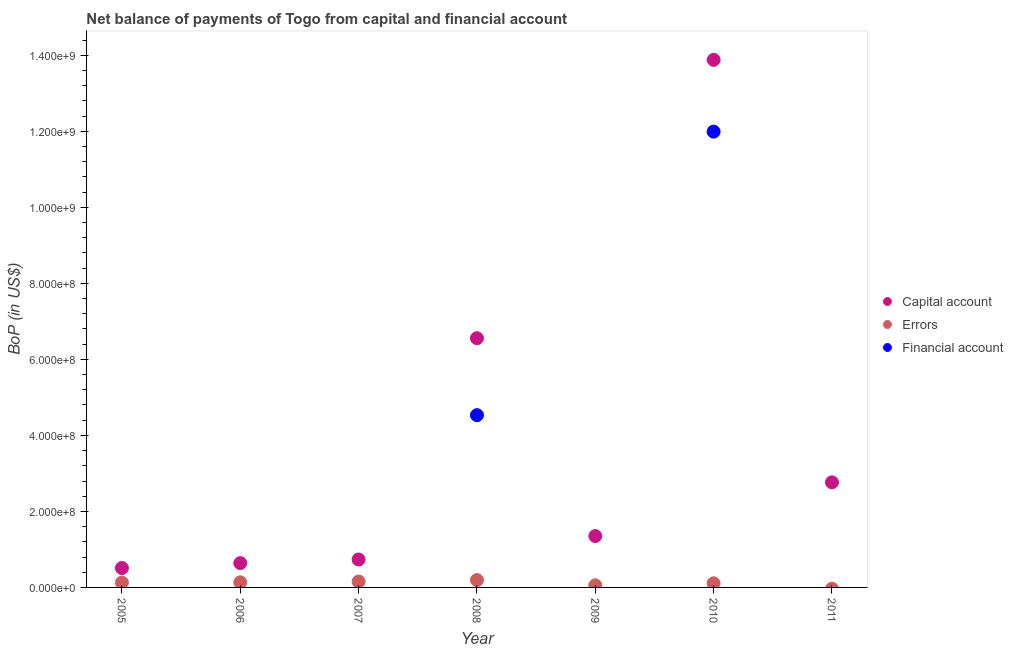How many different coloured dotlines are there?
Your response must be concise. 3. Is the number of dotlines equal to the number of legend labels?
Provide a short and direct response. No. Across all years, what is the maximum amount of net capital account?
Make the answer very short. 1.39e+09. Across all years, what is the minimum amount of financial account?
Provide a succinct answer. 0. What is the total amount of net capital account in the graph?
Make the answer very short. 2.64e+09. What is the difference between the amount of errors in 2008 and that in 2010?
Ensure brevity in your answer.  8.51e+06. What is the difference between the amount of financial account in 2006 and the amount of net capital account in 2005?
Make the answer very short. -5.11e+07. What is the average amount of net capital account per year?
Keep it short and to the point. 3.78e+08. In the year 2010, what is the difference between the amount of financial account and amount of net capital account?
Ensure brevity in your answer.  -1.89e+08. What is the ratio of the amount of net capital account in 2006 to that in 2011?
Your response must be concise. 0.23. What is the difference between the highest and the second highest amount of net capital account?
Your answer should be very brief. 7.32e+08. What is the difference between the highest and the lowest amount of errors?
Your response must be concise. 1.94e+07. In how many years, is the amount of errors greater than the average amount of errors taken over all years?
Keep it short and to the point. 4. Is the sum of the amount of net capital account in 2008 and 2011 greater than the maximum amount of errors across all years?
Keep it short and to the point. Yes. Does the amount of errors monotonically increase over the years?
Offer a terse response. No. Is the amount of net capital account strictly greater than the amount of errors over the years?
Provide a succinct answer. Yes. How many dotlines are there?
Your response must be concise. 3. How many years are there in the graph?
Provide a succinct answer. 7. What is the difference between two consecutive major ticks on the Y-axis?
Make the answer very short. 2.00e+08. Does the graph contain any zero values?
Keep it short and to the point. Yes. Where does the legend appear in the graph?
Your answer should be compact. Center right. How many legend labels are there?
Offer a very short reply. 3. How are the legend labels stacked?
Give a very brief answer. Vertical. What is the title of the graph?
Keep it short and to the point. Net balance of payments of Togo from capital and financial account. Does "Methane" appear as one of the legend labels in the graph?
Your answer should be very brief. No. What is the label or title of the X-axis?
Your answer should be compact. Year. What is the label or title of the Y-axis?
Your answer should be compact. BoP (in US$). What is the BoP (in US$) in Capital account in 2005?
Ensure brevity in your answer.  5.11e+07. What is the BoP (in US$) in Errors in 2005?
Make the answer very short. 1.28e+07. What is the BoP (in US$) in Capital account in 2006?
Ensure brevity in your answer.  6.40e+07. What is the BoP (in US$) of Errors in 2006?
Ensure brevity in your answer.  1.34e+07. What is the BoP (in US$) in Capital account in 2007?
Give a very brief answer. 7.34e+07. What is the BoP (in US$) in Errors in 2007?
Make the answer very short. 1.54e+07. What is the BoP (in US$) in Financial account in 2007?
Ensure brevity in your answer.  0. What is the BoP (in US$) of Capital account in 2008?
Give a very brief answer. 6.56e+08. What is the BoP (in US$) in Errors in 2008?
Provide a succinct answer. 1.94e+07. What is the BoP (in US$) of Financial account in 2008?
Your answer should be compact. 4.53e+08. What is the BoP (in US$) in Capital account in 2009?
Provide a succinct answer. 1.35e+08. What is the BoP (in US$) in Errors in 2009?
Offer a very short reply. 5.51e+06. What is the BoP (in US$) of Financial account in 2009?
Make the answer very short. 0. What is the BoP (in US$) in Capital account in 2010?
Make the answer very short. 1.39e+09. What is the BoP (in US$) of Errors in 2010?
Keep it short and to the point. 1.09e+07. What is the BoP (in US$) in Financial account in 2010?
Give a very brief answer. 1.20e+09. What is the BoP (in US$) of Capital account in 2011?
Offer a very short reply. 2.76e+08. What is the BoP (in US$) of Errors in 2011?
Offer a terse response. 0. Across all years, what is the maximum BoP (in US$) of Capital account?
Provide a succinct answer. 1.39e+09. Across all years, what is the maximum BoP (in US$) of Errors?
Ensure brevity in your answer.  1.94e+07. Across all years, what is the maximum BoP (in US$) in Financial account?
Offer a very short reply. 1.20e+09. Across all years, what is the minimum BoP (in US$) of Capital account?
Provide a succinct answer. 5.11e+07. Across all years, what is the minimum BoP (in US$) in Financial account?
Offer a terse response. 0. What is the total BoP (in US$) in Capital account in the graph?
Your answer should be very brief. 2.64e+09. What is the total BoP (in US$) in Errors in the graph?
Your answer should be compact. 7.73e+07. What is the total BoP (in US$) in Financial account in the graph?
Provide a succinct answer. 1.65e+09. What is the difference between the BoP (in US$) of Capital account in 2005 and that in 2006?
Provide a succinct answer. -1.29e+07. What is the difference between the BoP (in US$) of Errors in 2005 and that in 2006?
Provide a succinct answer. -5.96e+05. What is the difference between the BoP (in US$) in Capital account in 2005 and that in 2007?
Give a very brief answer. -2.24e+07. What is the difference between the BoP (in US$) in Errors in 2005 and that in 2007?
Your response must be concise. -2.56e+06. What is the difference between the BoP (in US$) in Capital account in 2005 and that in 2008?
Provide a succinct answer. -6.05e+08. What is the difference between the BoP (in US$) of Errors in 2005 and that in 2008?
Offer a terse response. -6.60e+06. What is the difference between the BoP (in US$) in Capital account in 2005 and that in 2009?
Your answer should be compact. -8.41e+07. What is the difference between the BoP (in US$) of Errors in 2005 and that in 2009?
Provide a succinct answer. 7.29e+06. What is the difference between the BoP (in US$) of Capital account in 2005 and that in 2010?
Offer a terse response. -1.34e+09. What is the difference between the BoP (in US$) of Errors in 2005 and that in 2010?
Give a very brief answer. 1.91e+06. What is the difference between the BoP (in US$) of Capital account in 2005 and that in 2011?
Make the answer very short. -2.25e+08. What is the difference between the BoP (in US$) of Capital account in 2006 and that in 2007?
Provide a short and direct response. -9.43e+06. What is the difference between the BoP (in US$) of Errors in 2006 and that in 2007?
Give a very brief answer. -1.96e+06. What is the difference between the BoP (in US$) of Capital account in 2006 and that in 2008?
Ensure brevity in your answer.  -5.92e+08. What is the difference between the BoP (in US$) in Errors in 2006 and that in 2008?
Provide a short and direct response. -6.00e+06. What is the difference between the BoP (in US$) in Capital account in 2006 and that in 2009?
Offer a very short reply. -7.12e+07. What is the difference between the BoP (in US$) of Errors in 2006 and that in 2009?
Your answer should be very brief. 7.88e+06. What is the difference between the BoP (in US$) of Capital account in 2006 and that in 2010?
Ensure brevity in your answer.  -1.32e+09. What is the difference between the BoP (in US$) of Errors in 2006 and that in 2010?
Give a very brief answer. 2.50e+06. What is the difference between the BoP (in US$) in Capital account in 2006 and that in 2011?
Make the answer very short. -2.12e+08. What is the difference between the BoP (in US$) of Capital account in 2007 and that in 2008?
Keep it short and to the point. -5.82e+08. What is the difference between the BoP (in US$) of Errors in 2007 and that in 2008?
Ensure brevity in your answer.  -4.04e+06. What is the difference between the BoP (in US$) in Capital account in 2007 and that in 2009?
Your answer should be compact. -6.17e+07. What is the difference between the BoP (in US$) in Errors in 2007 and that in 2009?
Ensure brevity in your answer.  9.85e+06. What is the difference between the BoP (in US$) in Capital account in 2007 and that in 2010?
Provide a short and direct response. -1.31e+09. What is the difference between the BoP (in US$) of Errors in 2007 and that in 2010?
Provide a short and direct response. 4.47e+06. What is the difference between the BoP (in US$) in Capital account in 2007 and that in 2011?
Provide a succinct answer. -2.03e+08. What is the difference between the BoP (in US$) of Capital account in 2008 and that in 2009?
Offer a very short reply. 5.21e+08. What is the difference between the BoP (in US$) in Errors in 2008 and that in 2009?
Your response must be concise. 1.39e+07. What is the difference between the BoP (in US$) in Capital account in 2008 and that in 2010?
Give a very brief answer. -7.32e+08. What is the difference between the BoP (in US$) in Errors in 2008 and that in 2010?
Give a very brief answer. 8.51e+06. What is the difference between the BoP (in US$) in Financial account in 2008 and that in 2010?
Your response must be concise. -7.46e+08. What is the difference between the BoP (in US$) of Capital account in 2008 and that in 2011?
Offer a very short reply. 3.79e+08. What is the difference between the BoP (in US$) of Capital account in 2009 and that in 2010?
Make the answer very short. -1.25e+09. What is the difference between the BoP (in US$) in Errors in 2009 and that in 2010?
Offer a very short reply. -5.38e+06. What is the difference between the BoP (in US$) of Capital account in 2009 and that in 2011?
Provide a succinct answer. -1.41e+08. What is the difference between the BoP (in US$) of Capital account in 2010 and that in 2011?
Your response must be concise. 1.11e+09. What is the difference between the BoP (in US$) of Capital account in 2005 and the BoP (in US$) of Errors in 2006?
Your answer should be very brief. 3.77e+07. What is the difference between the BoP (in US$) of Capital account in 2005 and the BoP (in US$) of Errors in 2007?
Give a very brief answer. 3.57e+07. What is the difference between the BoP (in US$) in Capital account in 2005 and the BoP (in US$) in Errors in 2008?
Offer a terse response. 3.17e+07. What is the difference between the BoP (in US$) in Capital account in 2005 and the BoP (in US$) in Financial account in 2008?
Provide a succinct answer. -4.02e+08. What is the difference between the BoP (in US$) in Errors in 2005 and the BoP (in US$) in Financial account in 2008?
Your answer should be very brief. -4.40e+08. What is the difference between the BoP (in US$) in Capital account in 2005 and the BoP (in US$) in Errors in 2009?
Keep it short and to the point. 4.55e+07. What is the difference between the BoP (in US$) of Capital account in 2005 and the BoP (in US$) of Errors in 2010?
Your answer should be very brief. 4.02e+07. What is the difference between the BoP (in US$) in Capital account in 2005 and the BoP (in US$) in Financial account in 2010?
Ensure brevity in your answer.  -1.15e+09. What is the difference between the BoP (in US$) in Errors in 2005 and the BoP (in US$) in Financial account in 2010?
Your response must be concise. -1.19e+09. What is the difference between the BoP (in US$) of Capital account in 2006 and the BoP (in US$) of Errors in 2007?
Your response must be concise. 4.86e+07. What is the difference between the BoP (in US$) of Capital account in 2006 and the BoP (in US$) of Errors in 2008?
Your answer should be very brief. 4.46e+07. What is the difference between the BoP (in US$) in Capital account in 2006 and the BoP (in US$) in Financial account in 2008?
Offer a terse response. -3.89e+08. What is the difference between the BoP (in US$) in Errors in 2006 and the BoP (in US$) in Financial account in 2008?
Your response must be concise. -4.40e+08. What is the difference between the BoP (in US$) in Capital account in 2006 and the BoP (in US$) in Errors in 2009?
Your answer should be compact. 5.85e+07. What is the difference between the BoP (in US$) in Capital account in 2006 and the BoP (in US$) in Errors in 2010?
Make the answer very short. 5.31e+07. What is the difference between the BoP (in US$) of Capital account in 2006 and the BoP (in US$) of Financial account in 2010?
Your answer should be compact. -1.14e+09. What is the difference between the BoP (in US$) of Errors in 2006 and the BoP (in US$) of Financial account in 2010?
Your answer should be compact. -1.19e+09. What is the difference between the BoP (in US$) in Capital account in 2007 and the BoP (in US$) in Errors in 2008?
Offer a terse response. 5.40e+07. What is the difference between the BoP (in US$) in Capital account in 2007 and the BoP (in US$) in Financial account in 2008?
Give a very brief answer. -3.80e+08. What is the difference between the BoP (in US$) of Errors in 2007 and the BoP (in US$) of Financial account in 2008?
Offer a terse response. -4.38e+08. What is the difference between the BoP (in US$) of Capital account in 2007 and the BoP (in US$) of Errors in 2009?
Ensure brevity in your answer.  6.79e+07. What is the difference between the BoP (in US$) of Capital account in 2007 and the BoP (in US$) of Errors in 2010?
Make the answer very short. 6.25e+07. What is the difference between the BoP (in US$) of Capital account in 2007 and the BoP (in US$) of Financial account in 2010?
Your response must be concise. -1.13e+09. What is the difference between the BoP (in US$) of Errors in 2007 and the BoP (in US$) of Financial account in 2010?
Ensure brevity in your answer.  -1.18e+09. What is the difference between the BoP (in US$) of Capital account in 2008 and the BoP (in US$) of Errors in 2009?
Your answer should be compact. 6.50e+08. What is the difference between the BoP (in US$) in Capital account in 2008 and the BoP (in US$) in Errors in 2010?
Your answer should be very brief. 6.45e+08. What is the difference between the BoP (in US$) in Capital account in 2008 and the BoP (in US$) in Financial account in 2010?
Ensure brevity in your answer.  -5.43e+08. What is the difference between the BoP (in US$) in Errors in 2008 and the BoP (in US$) in Financial account in 2010?
Ensure brevity in your answer.  -1.18e+09. What is the difference between the BoP (in US$) of Capital account in 2009 and the BoP (in US$) of Errors in 2010?
Provide a succinct answer. 1.24e+08. What is the difference between the BoP (in US$) of Capital account in 2009 and the BoP (in US$) of Financial account in 2010?
Give a very brief answer. -1.06e+09. What is the difference between the BoP (in US$) in Errors in 2009 and the BoP (in US$) in Financial account in 2010?
Give a very brief answer. -1.19e+09. What is the average BoP (in US$) of Capital account per year?
Your answer should be compact. 3.78e+08. What is the average BoP (in US$) of Errors per year?
Your response must be concise. 1.10e+07. What is the average BoP (in US$) in Financial account per year?
Offer a very short reply. 2.36e+08. In the year 2005, what is the difference between the BoP (in US$) of Capital account and BoP (in US$) of Errors?
Provide a succinct answer. 3.83e+07. In the year 2006, what is the difference between the BoP (in US$) in Capital account and BoP (in US$) in Errors?
Give a very brief answer. 5.06e+07. In the year 2007, what is the difference between the BoP (in US$) of Capital account and BoP (in US$) of Errors?
Your answer should be compact. 5.81e+07. In the year 2008, what is the difference between the BoP (in US$) of Capital account and BoP (in US$) of Errors?
Your response must be concise. 6.36e+08. In the year 2008, what is the difference between the BoP (in US$) in Capital account and BoP (in US$) in Financial account?
Provide a succinct answer. 2.03e+08. In the year 2008, what is the difference between the BoP (in US$) in Errors and BoP (in US$) in Financial account?
Provide a succinct answer. -4.34e+08. In the year 2009, what is the difference between the BoP (in US$) in Capital account and BoP (in US$) in Errors?
Your response must be concise. 1.30e+08. In the year 2010, what is the difference between the BoP (in US$) in Capital account and BoP (in US$) in Errors?
Offer a very short reply. 1.38e+09. In the year 2010, what is the difference between the BoP (in US$) in Capital account and BoP (in US$) in Financial account?
Make the answer very short. 1.89e+08. In the year 2010, what is the difference between the BoP (in US$) in Errors and BoP (in US$) in Financial account?
Make the answer very short. -1.19e+09. What is the ratio of the BoP (in US$) of Capital account in 2005 to that in 2006?
Keep it short and to the point. 0.8. What is the ratio of the BoP (in US$) of Errors in 2005 to that in 2006?
Your answer should be very brief. 0.96. What is the ratio of the BoP (in US$) of Capital account in 2005 to that in 2007?
Offer a very short reply. 0.7. What is the ratio of the BoP (in US$) in Errors in 2005 to that in 2007?
Provide a succinct answer. 0.83. What is the ratio of the BoP (in US$) of Capital account in 2005 to that in 2008?
Provide a succinct answer. 0.08. What is the ratio of the BoP (in US$) of Errors in 2005 to that in 2008?
Provide a short and direct response. 0.66. What is the ratio of the BoP (in US$) in Capital account in 2005 to that in 2009?
Make the answer very short. 0.38. What is the ratio of the BoP (in US$) of Errors in 2005 to that in 2009?
Your answer should be compact. 2.32. What is the ratio of the BoP (in US$) in Capital account in 2005 to that in 2010?
Make the answer very short. 0.04. What is the ratio of the BoP (in US$) of Errors in 2005 to that in 2010?
Offer a terse response. 1.18. What is the ratio of the BoP (in US$) of Capital account in 2005 to that in 2011?
Ensure brevity in your answer.  0.18. What is the ratio of the BoP (in US$) of Capital account in 2006 to that in 2007?
Your answer should be very brief. 0.87. What is the ratio of the BoP (in US$) in Errors in 2006 to that in 2007?
Offer a very short reply. 0.87. What is the ratio of the BoP (in US$) of Capital account in 2006 to that in 2008?
Offer a terse response. 0.1. What is the ratio of the BoP (in US$) in Errors in 2006 to that in 2008?
Your answer should be compact. 0.69. What is the ratio of the BoP (in US$) of Capital account in 2006 to that in 2009?
Give a very brief answer. 0.47. What is the ratio of the BoP (in US$) in Errors in 2006 to that in 2009?
Your response must be concise. 2.43. What is the ratio of the BoP (in US$) of Capital account in 2006 to that in 2010?
Your answer should be compact. 0.05. What is the ratio of the BoP (in US$) in Errors in 2006 to that in 2010?
Your answer should be compact. 1.23. What is the ratio of the BoP (in US$) in Capital account in 2006 to that in 2011?
Provide a short and direct response. 0.23. What is the ratio of the BoP (in US$) of Capital account in 2007 to that in 2008?
Keep it short and to the point. 0.11. What is the ratio of the BoP (in US$) in Errors in 2007 to that in 2008?
Provide a succinct answer. 0.79. What is the ratio of the BoP (in US$) in Capital account in 2007 to that in 2009?
Offer a terse response. 0.54. What is the ratio of the BoP (in US$) of Errors in 2007 to that in 2009?
Make the answer very short. 2.79. What is the ratio of the BoP (in US$) of Capital account in 2007 to that in 2010?
Provide a succinct answer. 0.05. What is the ratio of the BoP (in US$) of Errors in 2007 to that in 2010?
Give a very brief answer. 1.41. What is the ratio of the BoP (in US$) of Capital account in 2007 to that in 2011?
Offer a terse response. 0.27. What is the ratio of the BoP (in US$) of Capital account in 2008 to that in 2009?
Give a very brief answer. 4.85. What is the ratio of the BoP (in US$) of Errors in 2008 to that in 2009?
Your response must be concise. 3.52. What is the ratio of the BoP (in US$) of Capital account in 2008 to that in 2010?
Your answer should be compact. 0.47. What is the ratio of the BoP (in US$) of Errors in 2008 to that in 2010?
Give a very brief answer. 1.78. What is the ratio of the BoP (in US$) in Financial account in 2008 to that in 2010?
Give a very brief answer. 0.38. What is the ratio of the BoP (in US$) of Capital account in 2008 to that in 2011?
Give a very brief answer. 2.37. What is the ratio of the BoP (in US$) in Capital account in 2009 to that in 2010?
Offer a very short reply. 0.1. What is the ratio of the BoP (in US$) in Errors in 2009 to that in 2010?
Your response must be concise. 0.51. What is the ratio of the BoP (in US$) in Capital account in 2009 to that in 2011?
Provide a succinct answer. 0.49. What is the ratio of the BoP (in US$) of Capital account in 2010 to that in 2011?
Provide a short and direct response. 5.02. What is the difference between the highest and the second highest BoP (in US$) in Capital account?
Ensure brevity in your answer.  7.32e+08. What is the difference between the highest and the second highest BoP (in US$) in Errors?
Offer a terse response. 4.04e+06. What is the difference between the highest and the lowest BoP (in US$) of Capital account?
Ensure brevity in your answer.  1.34e+09. What is the difference between the highest and the lowest BoP (in US$) in Errors?
Provide a short and direct response. 1.94e+07. What is the difference between the highest and the lowest BoP (in US$) of Financial account?
Offer a terse response. 1.20e+09. 